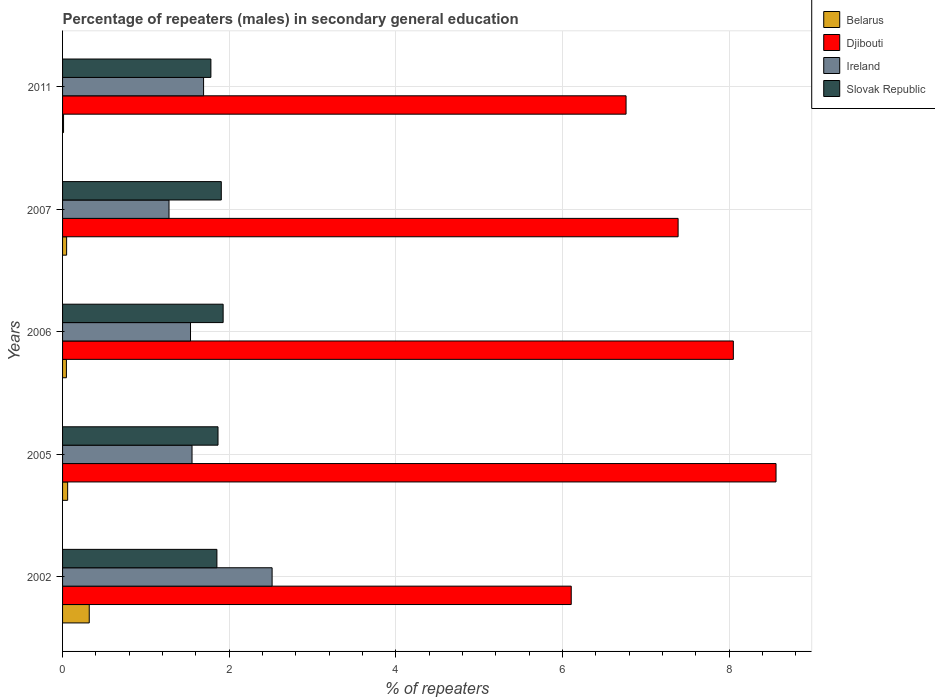Are the number of bars per tick equal to the number of legend labels?
Give a very brief answer. Yes. How many bars are there on the 2nd tick from the bottom?
Ensure brevity in your answer.  4. In how many cases, is the number of bars for a given year not equal to the number of legend labels?
Keep it short and to the point. 0. What is the percentage of male repeaters in Slovak Republic in 2002?
Provide a short and direct response. 1.85. Across all years, what is the maximum percentage of male repeaters in Belarus?
Offer a terse response. 0.32. Across all years, what is the minimum percentage of male repeaters in Djibouti?
Make the answer very short. 6.1. In which year was the percentage of male repeaters in Belarus maximum?
Your answer should be very brief. 2002. What is the total percentage of male repeaters in Djibouti in the graph?
Provide a succinct answer. 36.87. What is the difference between the percentage of male repeaters in Slovak Republic in 2002 and that in 2006?
Your response must be concise. -0.07. What is the difference between the percentage of male repeaters in Ireland in 2011 and the percentage of male repeaters in Belarus in 2002?
Your answer should be compact. 1.37. What is the average percentage of male repeaters in Djibouti per year?
Offer a terse response. 7.37. In the year 2005, what is the difference between the percentage of male repeaters in Slovak Republic and percentage of male repeaters in Belarus?
Ensure brevity in your answer.  1.8. In how many years, is the percentage of male repeaters in Belarus greater than 8.4 %?
Ensure brevity in your answer.  0. What is the ratio of the percentage of male repeaters in Slovak Republic in 2002 to that in 2007?
Make the answer very short. 0.97. What is the difference between the highest and the second highest percentage of male repeaters in Djibouti?
Make the answer very short. 0.51. What is the difference between the highest and the lowest percentage of male repeaters in Slovak Republic?
Offer a very short reply. 0.15. Is it the case that in every year, the sum of the percentage of male repeaters in Ireland and percentage of male repeaters in Belarus is greater than the sum of percentage of male repeaters in Djibouti and percentage of male repeaters in Slovak Republic?
Provide a short and direct response. Yes. What does the 3rd bar from the top in 2007 represents?
Your response must be concise. Djibouti. What does the 2nd bar from the bottom in 2007 represents?
Ensure brevity in your answer.  Djibouti. Is it the case that in every year, the sum of the percentage of male repeaters in Slovak Republic and percentage of male repeaters in Ireland is greater than the percentage of male repeaters in Djibouti?
Keep it short and to the point. No. What is the difference between two consecutive major ticks on the X-axis?
Provide a succinct answer. 2. Does the graph contain grids?
Your answer should be very brief. Yes. How are the legend labels stacked?
Provide a short and direct response. Vertical. What is the title of the graph?
Your response must be concise. Percentage of repeaters (males) in secondary general education. Does "United States" appear as one of the legend labels in the graph?
Your response must be concise. No. What is the label or title of the X-axis?
Your answer should be compact. % of repeaters. What is the % of repeaters in Belarus in 2002?
Your response must be concise. 0.32. What is the % of repeaters of Djibouti in 2002?
Provide a short and direct response. 6.1. What is the % of repeaters in Ireland in 2002?
Your answer should be compact. 2.51. What is the % of repeaters in Slovak Republic in 2002?
Provide a short and direct response. 1.85. What is the % of repeaters in Belarus in 2005?
Make the answer very short. 0.06. What is the % of repeaters of Djibouti in 2005?
Ensure brevity in your answer.  8.56. What is the % of repeaters in Ireland in 2005?
Give a very brief answer. 1.55. What is the % of repeaters of Slovak Republic in 2005?
Your answer should be very brief. 1.87. What is the % of repeaters of Belarus in 2006?
Keep it short and to the point. 0.05. What is the % of repeaters of Djibouti in 2006?
Offer a very short reply. 8.05. What is the % of repeaters in Ireland in 2006?
Offer a very short reply. 1.54. What is the % of repeaters of Slovak Republic in 2006?
Give a very brief answer. 1.93. What is the % of repeaters of Belarus in 2007?
Keep it short and to the point. 0.05. What is the % of repeaters in Djibouti in 2007?
Offer a very short reply. 7.39. What is the % of repeaters of Ireland in 2007?
Ensure brevity in your answer.  1.28. What is the % of repeaters in Slovak Republic in 2007?
Your answer should be compact. 1.9. What is the % of repeaters in Belarus in 2011?
Make the answer very short. 0.01. What is the % of repeaters in Djibouti in 2011?
Make the answer very short. 6.76. What is the % of repeaters of Ireland in 2011?
Your answer should be very brief. 1.69. What is the % of repeaters of Slovak Republic in 2011?
Make the answer very short. 1.78. Across all years, what is the maximum % of repeaters in Belarus?
Provide a short and direct response. 0.32. Across all years, what is the maximum % of repeaters in Djibouti?
Offer a very short reply. 8.56. Across all years, what is the maximum % of repeaters in Ireland?
Make the answer very short. 2.51. Across all years, what is the maximum % of repeaters in Slovak Republic?
Offer a very short reply. 1.93. Across all years, what is the minimum % of repeaters in Belarus?
Provide a short and direct response. 0.01. Across all years, what is the minimum % of repeaters in Djibouti?
Offer a terse response. 6.1. Across all years, what is the minimum % of repeaters of Ireland?
Keep it short and to the point. 1.28. Across all years, what is the minimum % of repeaters in Slovak Republic?
Offer a terse response. 1.78. What is the total % of repeaters in Belarus in the graph?
Make the answer very short. 0.49. What is the total % of repeaters of Djibouti in the graph?
Offer a terse response. 36.87. What is the total % of repeaters in Ireland in the graph?
Offer a terse response. 8.57. What is the total % of repeaters in Slovak Republic in the graph?
Offer a terse response. 9.33. What is the difference between the % of repeaters in Belarus in 2002 and that in 2005?
Offer a terse response. 0.26. What is the difference between the % of repeaters in Djibouti in 2002 and that in 2005?
Provide a short and direct response. -2.46. What is the difference between the % of repeaters in Ireland in 2002 and that in 2005?
Your answer should be very brief. 0.96. What is the difference between the % of repeaters of Slovak Republic in 2002 and that in 2005?
Offer a terse response. -0.01. What is the difference between the % of repeaters of Belarus in 2002 and that in 2006?
Make the answer very short. 0.27. What is the difference between the % of repeaters in Djibouti in 2002 and that in 2006?
Offer a very short reply. -1.95. What is the difference between the % of repeaters in Ireland in 2002 and that in 2006?
Ensure brevity in your answer.  0.98. What is the difference between the % of repeaters of Slovak Republic in 2002 and that in 2006?
Your answer should be very brief. -0.07. What is the difference between the % of repeaters of Belarus in 2002 and that in 2007?
Your response must be concise. 0.27. What is the difference between the % of repeaters in Djibouti in 2002 and that in 2007?
Make the answer very short. -1.28. What is the difference between the % of repeaters in Ireland in 2002 and that in 2007?
Make the answer very short. 1.24. What is the difference between the % of repeaters in Slovak Republic in 2002 and that in 2007?
Your answer should be compact. -0.05. What is the difference between the % of repeaters in Belarus in 2002 and that in 2011?
Make the answer very short. 0.31. What is the difference between the % of repeaters of Djibouti in 2002 and that in 2011?
Provide a short and direct response. -0.66. What is the difference between the % of repeaters in Ireland in 2002 and that in 2011?
Offer a terse response. 0.82. What is the difference between the % of repeaters of Slovak Republic in 2002 and that in 2011?
Provide a succinct answer. 0.07. What is the difference between the % of repeaters of Belarus in 2005 and that in 2006?
Give a very brief answer. 0.02. What is the difference between the % of repeaters of Djibouti in 2005 and that in 2006?
Keep it short and to the point. 0.51. What is the difference between the % of repeaters in Ireland in 2005 and that in 2006?
Keep it short and to the point. 0.02. What is the difference between the % of repeaters in Slovak Republic in 2005 and that in 2006?
Keep it short and to the point. -0.06. What is the difference between the % of repeaters of Belarus in 2005 and that in 2007?
Make the answer very short. 0.01. What is the difference between the % of repeaters of Djibouti in 2005 and that in 2007?
Make the answer very short. 1.18. What is the difference between the % of repeaters of Ireland in 2005 and that in 2007?
Provide a short and direct response. 0.28. What is the difference between the % of repeaters of Slovak Republic in 2005 and that in 2007?
Ensure brevity in your answer.  -0.04. What is the difference between the % of repeaters of Belarus in 2005 and that in 2011?
Offer a very short reply. 0.05. What is the difference between the % of repeaters of Djibouti in 2005 and that in 2011?
Give a very brief answer. 1.8. What is the difference between the % of repeaters in Ireland in 2005 and that in 2011?
Your response must be concise. -0.14. What is the difference between the % of repeaters of Slovak Republic in 2005 and that in 2011?
Provide a succinct answer. 0.09. What is the difference between the % of repeaters of Belarus in 2006 and that in 2007?
Offer a terse response. -0. What is the difference between the % of repeaters of Djibouti in 2006 and that in 2007?
Make the answer very short. 0.66. What is the difference between the % of repeaters of Ireland in 2006 and that in 2007?
Your answer should be compact. 0.26. What is the difference between the % of repeaters of Slovak Republic in 2006 and that in 2007?
Provide a succinct answer. 0.02. What is the difference between the % of repeaters in Belarus in 2006 and that in 2011?
Your answer should be very brief. 0.03. What is the difference between the % of repeaters in Djibouti in 2006 and that in 2011?
Keep it short and to the point. 1.29. What is the difference between the % of repeaters of Ireland in 2006 and that in 2011?
Offer a terse response. -0.16. What is the difference between the % of repeaters in Slovak Republic in 2006 and that in 2011?
Your answer should be very brief. 0.15. What is the difference between the % of repeaters of Belarus in 2007 and that in 2011?
Ensure brevity in your answer.  0.04. What is the difference between the % of repeaters in Djibouti in 2007 and that in 2011?
Give a very brief answer. 0.62. What is the difference between the % of repeaters of Ireland in 2007 and that in 2011?
Offer a very short reply. -0.41. What is the difference between the % of repeaters in Slovak Republic in 2007 and that in 2011?
Ensure brevity in your answer.  0.12. What is the difference between the % of repeaters of Belarus in 2002 and the % of repeaters of Djibouti in 2005?
Make the answer very short. -8.24. What is the difference between the % of repeaters in Belarus in 2002 and the % of repeaters in Ireland in 2005?
Give a very brief answer. -1.23. What is the difference between the % of repeaters of Belarus in 2002 and the % of repeaters of Slovak Republic in 2005?
Your response must be concise. -1.55. What is the difference between the % of repeaters in Djibouti in 2002 and the % of repeaters in Ireland in 2005?
Ensure brevity in your answer.  4.55. What is the difference between the % of repeaters in Djibouti in 2002 and the % of repeaters in Slovak Republic in 2005?
Your response must be concise. 4.24. What is the difference between the % of repeaters in Ireland in 2002 and the % of repeaters in Slovak Republic in 2005?
Keep it short and to the point. 0.65. What is the difference between the % of repeaters in Belarus in 2002 and the % of repeaters in Djibouti in 2006?
Your response must be concise. -7.73. What is the difference between the % of repeaters of Belarus in 2002 and the % of repeaters of Ireland in 2006?
Give a very brief answer. -1.22. What is the difference between the % of repeaters in Belarus in 2002 and the % of repeaters in Slovak Republic in 2006?
Give a very brief answer. -1.61. What is the difference between the % of repeaters of Djibouti in 2002 and the % of repeaters of Ireland in 2006?
Provide a succinct answer. 4.57. What is the difference between the % of repeaters in Djibouti in 2002 and the % of repeaters in Slovak Republic in 2006?
Offer a terse response. 4.18. What is the difference between the % of repeaters of Ireland in 2002 and the % of repeaters of Slovak Republic in 2006?
Offer a very short reply. 0.59. What is the difference between the % of repeaters in Belarus in 2002 and the % of repeaters in Djibouti in 2007?
Offer a terse response. -7.07. What is the difference between the % of repeaters of Belarus in 2002 and the % of repeaters of Ireland in 2007?
Keep it short and to the point. -0.96. What is the difference between the % of repeaters of Belarus in 2002 and the % of repeaters of Slovak Republic in 2007?
Provide a short and direct response. -1.58. What is the difference between the % of repeaters in Djibouti in 2002 and the % of repeaters in Ireland in 2007?
Ensure brevity in your answer.  4.83. What is the difference between the % of repeaters of Djibouti in 2002 and the % of repeaters of Slovak Republic in 2007?
Your answer should be compact. 4.2. What is the difference between the % of repeaters in Ireland in 2002 and the % of repeaters in Slovak Republic in 2007?
Offer a terse response. 0.61. What is the difference between the % of repeaters in Belarus in 2002 and the % of repeaters in Djibouti in 2011?
Your answer should be compact. -6.44. What is the difference between the % of repeaters of Belarus in 2002 and the % of repeaters of Ireland in 2011?
Your answer should be very brief. -1.37. What is the difference between the % of repeaters of Belarus in 2002 and the % of repeaters of Slovak Republic in 2011?
Ensure brevity in your answer.  -1.46. What is the difference between the % of repeaters of Djibouti in 2002 and the % of repeaters of Ireland in 2011?
Give a very brief answer. 4.41. What is the difference between the % of repeaters in Djibouti in 2002 and the % of repeaters in Slovak Republic in 2011?
Provide a short and direct response. 4.32. What is the difference between the % of repeaters of Ireland in 2002 and the % of repeaters of Slovak Republic in 2011?
Offer a terse response. 0.73. What is the difference between the % of repeaters of Belarus in 2005 and the % of repeaters of Djibouti in 2006?
Keep it short and to the point. -7.99. What is the difference between the % of repeaters in Belarus in 2005 and the % of repeaters in Ireland in 2006?
Provide a succinct answer. -1.47. What is the difference between the % of repeaters in Belarus in 2005 and the % of repeaters in Slovak Republic in 2006?
Offer a very short reply. -1.87. What is the difference between the % of repeaters of Djibouti in 2005 and the % of repeaters of Ireland in 2006?
Offer a terse response. 7.03. What is the difference between the % of repeaters of Djibouti in 2005 and the % of repeaters of Slovak Republic in 2006?
Provide a succinct answer. 6.63. What is the difference between the % of repeaters in Ireland in 2005 and the % of repeaters in Slovak Republic in 2006?
Offer a terse response. -0.37. What is the difference between the % of repeaters in Belarus in 2005 and the % of repeaters in Djibouti in 2007?
Offer a very short reply. -7.33. What is the difference between the % of repeaters of Belarus in 2005 and the % of repeaters of Ireland in 2007?
Provide a short and direct response. -1.22. What is the difference between the % of repeaters in Belarus in 2005 and the % of repeaters in Slovak Republic in 2007?
Offer a terse response. -1.84. What is the difference between the % of repeaters of Djibouti in 2005 and the % of repeaters of Ireland in 2007?
Make the answer very short. 7.28. What is the difference between the % of repeaters in Djibouti in 2005 and the % of repeaters in Slovak Republic in 2007?
Your answer should be very brief. 6.66. What is the difference between the % of repeaters of Ireland in 2005 and the % of repeaters of Slovak Republic in 2007?
Give a very brief answer. -0.35. What is the difference between the % of repeaters of Belarus in 2005 and the % of repeaters of Djibouti in 2011?
Keep it short and to the point. -6.7. What is the difference between the % of repeaters of Belarus in 2005 and the % of repeaters of Ireland in 2011?
Offer a very short reply. -1.63. What is the difference between the % of repeaters of Belarus in 2005 and the % of repeaters of Slovak Republic in 2011?
Your answer should be very brief. -1.72. What is the difference between the % of repeaters in Djibouti in 2005 and the % of repeaters in Ireland in 2011?
Offer a terse response. 6.87. What is the difference between the % of repeaters of Djibouti in 2005 and the % of repeaters of Slovak Republic in 2011?
Provide a short and direct response. 6.78. What is the difference between the % of repeaters of Ireland in 2005 and the % of repeaters of Slovak Republic in 2011?
Offer a terse response. -0.23. What is the difference between the % of repeaters of Belarus in 2006 and the % of repeaters of Djibouti in 2007?
Your answer should be compact. -7.34. What is the difference between the % of repeaters of Belarus in 2006 and the % of repeaters of Ireland in 2007?
Your response must be concise. -1.23. What is the difference between the % of repeaters of Belarus in 2006 and the % of repeaters of Slovak Republic in 2007?
Your response must be concise. -1.86. What is the difference between the % of repeaters of Djibouti in 2006 and the % of repeaters of Ireland in 2007?
Your answer should be very brief. 6.77. What is the difference between the % of repeaters in Djibouti in 2006 and the % of repeaters in Slovak Republic in 2007?
Ensure brevity in your answer.  6.14. What is the difference between the % of repeaters in Ireland in 2006 and the % of repeaters in Slovak Republic in 2007?
Your answer should be compact. -0.37. What is the difference between the % of repeaters of Belarus in 2006 and the % of repeaters of Djibouti in 2011?
Make the answer very short. -6.72. What is the difference between the % of repeaters of Belarus in 2006 and the % of repeaters of Ireland in 2011?
Make the answer very short. -1.65. What is the difference between the % of repeaters of Belarus in 2006 and the % of repeaters of Slovak Republic in 2011?
Make the answer very short. -1.73. What is the difference between the % of repeaters in Djibouti in 2006 and the % of repeaters in Ireland in 2011?
Give a very brief answer. 6.36. What is the difference between the % of repeaters of Djibouti in 2006 and the % of repeaters of Slovak Republic in 2011?
Give a very brief answer. 6.27. What is the difference between the % of repeaters in Ireland in 2006 and the % of repeaters in Slovak Republic in 2011?
Your response must be concise. -0.24. What is the difference between the % of repeaters of Belarus in 2007 and the % of repeaters of Djibouti in 2011?
Your answer should be compact. -6.71. What is the difference between the % of repeaters of Belarus in 2007 and the % of repeaters of Ireland in 2011?
Offer a very short reply. -1.64. What is the difference between the % of repeaters in Belarus in 2007 and the % of repeaters in Slovak Republic in 2011?
Offer a terse response. -1.73. What is the difference between the % of repeaters of Djibouti in 2007 and the % of repeaters of Ireland in 2011?
Make the answer very short. 5.69. What is the difference between the % of repeaters of Djibouti in 2007 and the % of repeaters of Slovak Republic in 2011?
Your answer should be compact. 5.61. What is the difference between the % of repeaters in Ireland in 2007 and the % of repeaters in Slovak Republic in 2011?
Ensure brevity in your answer.  -0.5. What is the average % of repeaters in Belarus per year?
Ensure brevity in your answer.  0.1. What is the average % of repeaters in Djibouti per year?
Make the answer very short. 7.37. What is the average % of repeaters in Ireland per year?
Ensure brevity in your answer.  1.71. What is the average % of repeaters of Slovak Republic per year?
Offer a very short reply. 1.87. In the year 2002, what is the difference between the % of repeaters of Belarus and % of repeaters of Djibouti?
Your answer should be compact. -5.78. In the year 2002, what is the difference between the % of repeaters of Belarus and % of repeaters of Ireland?
Give a very brief answer. -2.19. In the year 2002, what is the difference between the % of repeaters of Belarus and % of repeaters of Slovak Republic?
Offer a terse response. -1.53. In the year 2002, what is the difference between the % of repeaters of Djibouti and % of repeaters of Ireland?
Provide a succinct answer. 3.59. In the year 2002, what is the difference between the % of repeaters in Djibouti and % of repeaters in Slovak Republic?
Provide a short and direct response. 4.25. In the year 2002, what is the difference between the % of repeaters in Ireland and % of repeaters in Slovak Republic?
Keep it short and to the point. 0.66. In the year 2005, what is the difference between the % of repeaters in Belarus and % of repeaters in Djibouti?
Provide a succinct answer. -8.5. In the year 2005, what is the difference between the % of repeaters of Belarus and % of repeaters of Ireland?
Your response must be concise. -1.49. In the year 2005, what is the difference between the % of repeaters in Belarus and % of repeaters in Slovak Republic?
Make the answer very short. -1.8. In the year 2005, what is the difference between the % of repeaters of Djibouti and % of repeaters of Ireland?
Give a very brief answer. 7.01. In the year 2005, what is the difference between the % of repeaters in Djibouti and % of repeaters in Slovak Republic?
Offer a terse response. 6.7. In the year 2005, what is the difference between the % of repeaters in Ireland and % of repeaters in Slovak Republic?
Provide a short and direct response. -0.31. In the year 2006, what is the difference between the % of repeaters of Belarus and % of repeaters of Djibouti?
Offer a very short reply. -8. In the year 2006, what is the difference between the % of repeaters of Belarus and % of repeaters of Ireland?
Your response must be concise. -1.49. In the year 2006, what is the difference between the % of repeaters in Belarus and % of repeaters in Slovak Republic?
Keep it short and to the point. -1.88. In the year 2006, what is the difference between the % of repeaters in Djibouti and % of repeaters in Ireland?
Your answer should be compact. 6.51. In the year 2006, what is the difference between the % of repeaters in Djibouti and % of repeaters in Slovak Republic?
Keep it short and to the point. 6.12. In the year 2006, what is the difference between the % of repeaters in Ireland and % of repeaters in Slovak Republic?
Keep it short and to the point. -0.39. In the year 2007, what is the difference between the % of repeaters in Belarus and % of repeaters in Djibouti?
Ensure brevity in your answer.  -7.34. In the year 2007, what is the difference between the % of repeaters of Belarus and % of repeaters of Ireland?
Offer a very short reply. -1.23. In the year 2007, what is the difference between the % of repeaters in Belarus and % of repeaters in Slovak Republic?
Ensure brevity in your answer.  -1.86. In the year 2007, what is the difference between the % of repeaters of Djibouti and % of repeaters of Ireland?
Offer a terse response. 6.11. In the year 2007, what is the difference between the % of repeaters in Djibouti and % of repeaters in Slovak Republic?
Keep it short and to the point. 5.48. In the year 2007, what is the difference between the % of repeaters in Ireland and % of repeaters in Slovak Republic?
Your answer should be very brief. -0.63. In the year 2011, what is the difference between the % of repeaters of Belarus and % of repeaters of Djibouti?
Offer a terse response. -6.75. In the year 2011, what is the difference between the % of repeaters of Belarus and % of repeaters of Ireland?
Your answer should be compact. -1.68. In the year 2011, what is the difference between the % of repeaters in Belarus and % of repeaters in Slovak Republic?
Ensure brevity in your answer.  -1.77. In the year 2011, what is the difference between the % of repeaters of Djibouti and % of repeaters of Ireland?
Your response must be concise. 5.07. In the year 2011, what is the difference between the % of repeaters in Djibouti and % of repeaters in Slovak Republic?
Keep it short and to the point. 4.98. In the year 2011, what is the difference between the % of repeaters in Ireland and % of repeaters in Slovak Republic?
Offer a terse response. -0.09. What is the ratio of the % of repeaters of Belarus in 2002 to that in 2005?
Your answer should be compact. 5.24. What is the ratio of the % of repeaters in Djibouti in 2002 to that in 2005?
Give a very brief answer. 0.71. What is the ratio of the % of repeaters of Ireland in 2002 to that in 2005?
Your answer should be very brief. 1.62. What is the ratio of the % of repeaters of Slovak Republic in 2002 to that in 2005?
Keep it short and to the point. 0.99. What is the ratio of the % of repeaters in Belarus in 2002 to that in 2006?
Your response must be concise. 6.96. What is the ratio of the % of repeaters in Djibouti in 2002 to that in 2006?
Keep it short and to the point. 0.76. What is the ratio of the % of repeaters in Ireland in 2002 to that in 2006?
Provide a succinct answer. 1.64. What is the ratio of the % of repeaters of Slovak Republic in 2002 to that in 2006?
Make the answer very short. 0.96. What is the ratio of the % of repeaters in Belarus in 2002 to that in 2007?
Make the answer very short. 6.57. What is the ratio of the % of repeaters in Djibouti in 2002 to that in 2007?
Keep it short and to the point. 0.83. What is the ratio of the % of repeaters in Ireland in 2002 to that in 2007?
Keep it short and to the point. 1.97. What is the ratio of the % of repeaters of Slovak Republic in 2002 to that in 2007?
Make the answer very short. 0.97. What is the ratio of the % of repeaters in Belarus in 2002 to that in 2011?
Offer a very short reply. 27.22. What is the ratio of the % of repeaters in Djibouti in 2002 to that in 2011?
Give a very brief answer. 0.9. What is the ratio of the % of repeaters of Ireland in 2002 to that in 2011?
Your answer should be very brief. 1.49. What is the ratio of the % of repeaters of Slovak Republic in 2002 to that in 2011?
Make the answer very short. 1.04. What is the ratio of the % of repeaters in Belarus in 2005 to that in 2006?
Ensure brevity in your answer.  1.33. What is the ratio of the % of repeaters of Djibouti in 2005 to that in 2006?
Offer a very short reply. 1.06. What is the ratio of the % of repeaters in Ireland in 2005 to that in 2006?
Your response must be concise. 1.01. What is the ratio of the % of repeaters of Slovak Republic in 2005 to that in 2006?
Provide a short and direct response. 0.97. What is the ratio of the % of repeaters in Belarus in 2005 to that in 2007?
Provide a short and direct response. 1.26. What is the ratio of the % of repeaters of Djibouti in 2005 to that in 2007?
Provide a short and direct response. 1.16. What is the ratio of the % of repeaters of Ireland in 2005 to that in 2007?
Your answer should be compact. 1.22. What is the ratio of the % of repeaters in Slovak Republic in 2005 to that in 2007?
Keep it short and to the point. 0.98. What is the ratio of the % of repeaters of Belarus in 2005 to that in 2011?
Your answer should be compact. 5.2. What is the ratio of the % of repeaters in Djibouti in 2005 to that in 2011?
Provide a succinct answer. 1.27. What is the ratio of the % of repeaters of Ireland in 2005 to that in 2011?
Offer a very short reply. 0.92. What is the ratio of the % of repeaters of Slovak Republic in 2005 to that in 2011?
Offer a terse response. 1.05. What is the ratio of the % of repeaters in Belarus in 2006 to that in 2007?
Ensure brevity in your answer.  0.94. What is the ratio of the % of repeaters in Djibouti in 2006 to that in 2007?
Your answer should be compact. 1.09. What is the ratio of the % of repeaters of Ireland in 2006 to that in 2007?
Your answer should be compact. 1.2. What is the ratio of the % of repeaters in Slovak Republic in 2006 to that in 2007?
Your answer should be very brief. 1.01. What is the ratio of the % of repeaters in Belarus in 2006 to that in 2011?
Offer a terse response. 3.91. What is the ratio of the % of repeaters of Djibouti in 2006 to that in 2011?
Your answer should be very brief. 1.19. What is the ratio of the % of repeaters in Ireland in 2006 to that in 2011?
Provide a succinct answer. 0.91. What is the ratio of the % of repeaters of Slovak Republic in 2006 to that in 2011?
Your response must be concise. 1.08. What is the ratio of the % of repeaters in Belarus in 2007 to that in 2011?
Provide a short and direct response. 4.14. What is the ratio of the % of repeaters in Djibouti in 2007 to that in 2011?
Your answer should be very brief. 1.09. What is the ratio of the % of repeaters in Ireland in 2007 to that in 2011?
Provide a succinct answer. 0.75. What is the ratio of the % of repeaters of Slovak Republic in 2007 to that in 2011?
Provide a succinct answer. 1.07. What is the difference between the highest and the second highest % of repeaters of Belarus?
Provide a succinct answer. 0.26. What is the difference between the highest and the second highest % of repeaters in Djibouti?
Provide a short and direct response. 0.51. What is the difference between the highest and the second highest % of repeaters of Ireland?
Give a very brief answer. 0.82. What is the difference between the highest and the second highest % of repeaters of Slovak Republic?
Provide a short and direct response. 0.02. What is the difference between the highest and the lowest % of repeaters in Belarus?
Provide a short and direct response. 0.31. What is the difference between the highest and the lowest % of repeaters in Djibouti?
Keep it short and to the point. 2.46. What is the difference between the highest and the lowest % of repeaters in Ireland?
Offer a terse response. 1.24. What is the difference between the highest and the lowest % of repeaters of Slovak Republic?
Provide a short and direct response. 0.15. 